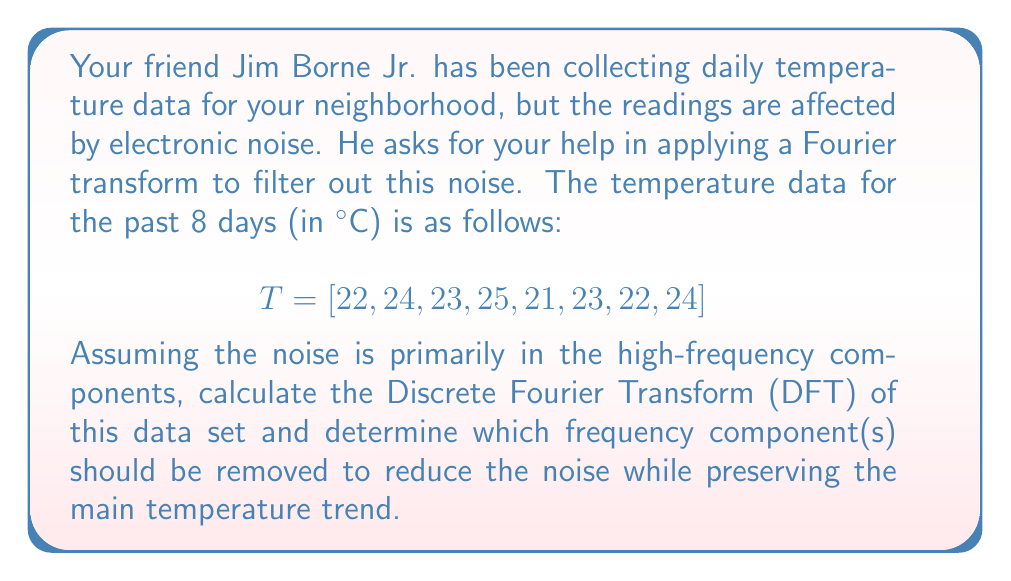Can you solve this math problem? Let's approach this step-by-step:

1) First, we need to calculate the Discrete Fourier Transform (DFT) of the temperature data. The DFT is given by:

   $$X[k] = \sum_{n=0}^{N-1} x[n] e^{-i2\pi kn/N}$$

   where $N = 8$ (number of data points), $k = 0, 1, ..., 7$, and $x[n]$ are the temperature values.

2) Calculating each component:

   $X[0] = 22 + 24 + 23 + 25 + 21 + 23 + 22 + 24 = 184$
   $X[1] = 22 + 24e^{-i\pi/4} + 23e^{-i\pi/2} + 25e^{-i3\pi/4} + 21e^{-i\pi} + 23e^{-i5\pi/4} + 22e^{-i3\pi/2} + 24e^{-i7\pi/4} = -1 - i$
   $X[2] = 22 + 24e^{-i\pi/2} + 23e^{-i\pi} + 25e^{-i3\pi/2} + 21e^{-i2\pi} + 23e^{-i5\pi/2} + 22e^{-i3\pi} + 24e^{-i7\pi/2} = 0 + 2i$
   $X[3] = 22 + 24e^{-i3\pi/4} + 23e^{-i3\pi/2} + 25e^{-i9\pi/4} + 21e^{-i3\pi} + 23e^{-i15\pi/4} + 22e^{-i9\pi/2} + 24e^{-i21\pi/4} = 1 - i$
   $X[4] = 22 + 24e^{-i\pi} + 23e^{-i2\pi} + 25e^{-i3\pi} + 21e^{-i4\pi} + 23e^{-i5\pi} + 22e^{-i6\pi} + 24e^{-i7\pi} = 0$

   Note: $X[5]$, $X[6]$, and $X[7]$ are complex conjugates of $X[3]$, $X[2]$, and $X[1]$ respectively.

3) The magnitude of these components represents their contribution to the signal:

   $|X[0]| = 184$ (DC component, average temperature)
   $|X[1]| = |X[7]| = \sqrt{2}$
   $|X[2]| = |X[6]| = 2$
   $|X[3]| = |X[5]| = \sqrt{2}$
   $|X[4]| = 0$

4) The higher frequency components (larger k values) typically correspond to noise. In this case, $X[3]$, $X[4]$, $X[5]$, $X[6]$, and $X[7]$ have relatively small magnitudes compared to the lower frequency components.

5) To reduce noise while preserving the main temperature trend, we should remove these higher frequency components (set them to zero) while keeping $X[0]$, $X[1]$, and $X[2]$ (and their conjugates).
Answer: Remove frequency components $X[3]$, $X[4]$, $X[5]$, $X[6]$, and $X[7]$. 